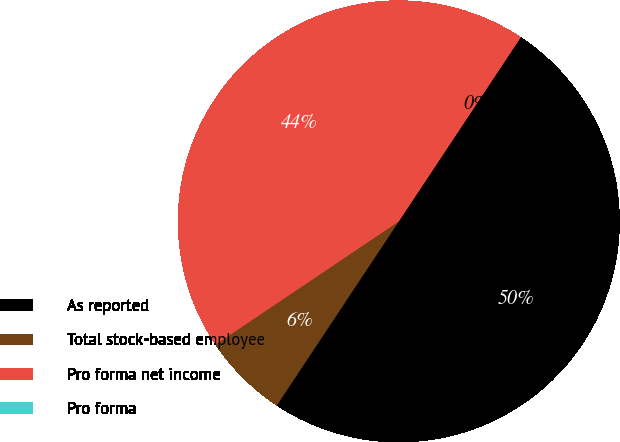<chart> <loc_0><loc_0><loc_500><loc_500><pie_chart><fcel>As reported<fcel>Total stock-based employee<fcel>Pro forma net income<fcel>Pro forma<nl><fcel>50.0%<fcel>6.26%<fcel>43.73%<fcel>0.0%<nl></chart> 